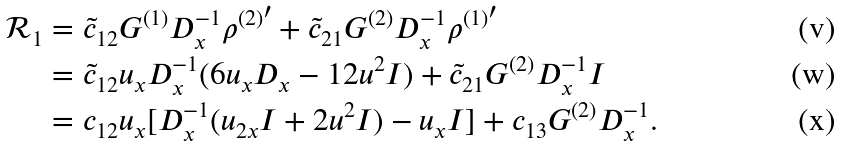<formula> <loc_0><loc_0><loc_500><loc_500>\mathcal { R } _ { 1 } & = \tilde { c } _ { 1 2 } G ^ { ( 1 ) } D _ { x } ^ { - 1 } { \rho ^ { ( 2 ) } } ^ { \prime } + \tilde { c } _ { 2 1 } G ^ { ( 2 ) } D _ { x } ^ { - 1 } { \rho ^ { ( 1 ) } } ^ { \prime } \\ & = \tilde { c } _ { 1 2 } u _ { x } D _ { x } ^ { - 1 } ( 6 u _ { x } D _ { x } - 1 2 u ^ { 2 } I ) + \tilde { c } _ { 2 1 } G ^ { ( 2 ) } D _ { x } ^ { - 1 } I \\ & = c _ { 1 2 } u _ { x } [ D _ { x } ^ { - 1 } ( u _ { 2 x } I + 2 u ^ { 2 } I ) - u _ { x } I ] + c _ { 1 3 } G ^ { ( 2 ) } D _ { x } ^ { - 1 } .</formula> 